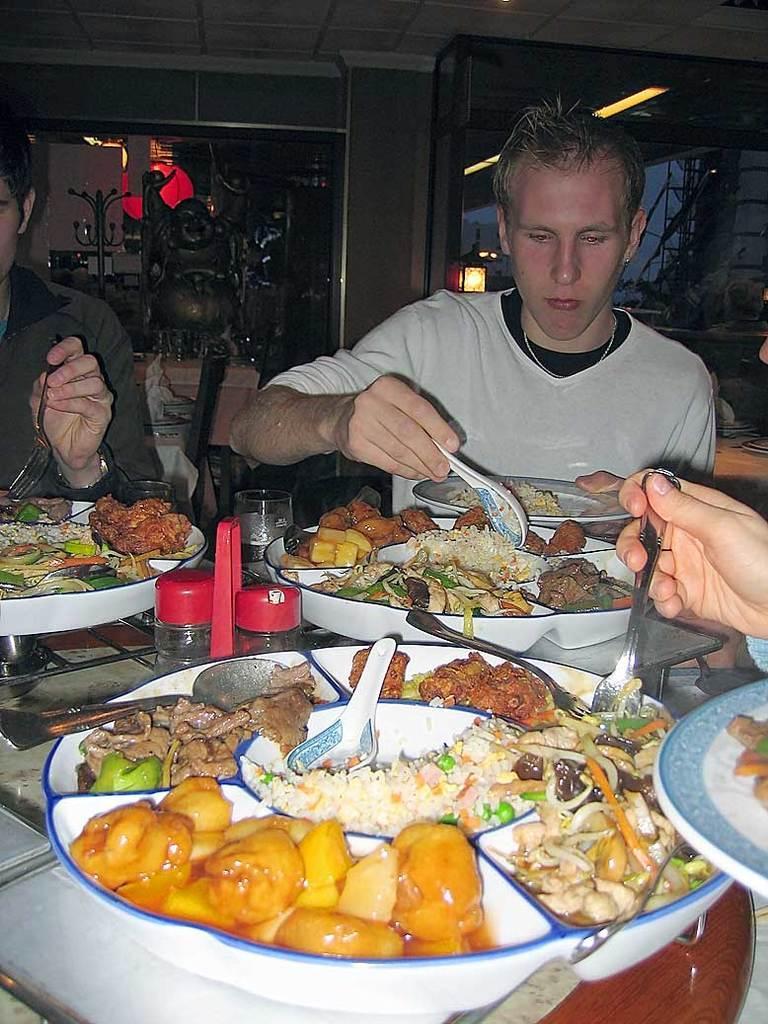How would you summarize this image in a sentence or two? In this picture, we see three people are sitting on the chair and they are holding the spoons and the forks in their hands. Two of them are holding the plates in their hands. In front of them, we see a table on which the plate containing foods, glasses and the glass bottles are placed. Behind them, we see a wall and the glass doors, We even see some other objects. On the right side, we see the lights and the glass door from which we can see a building in white color. 